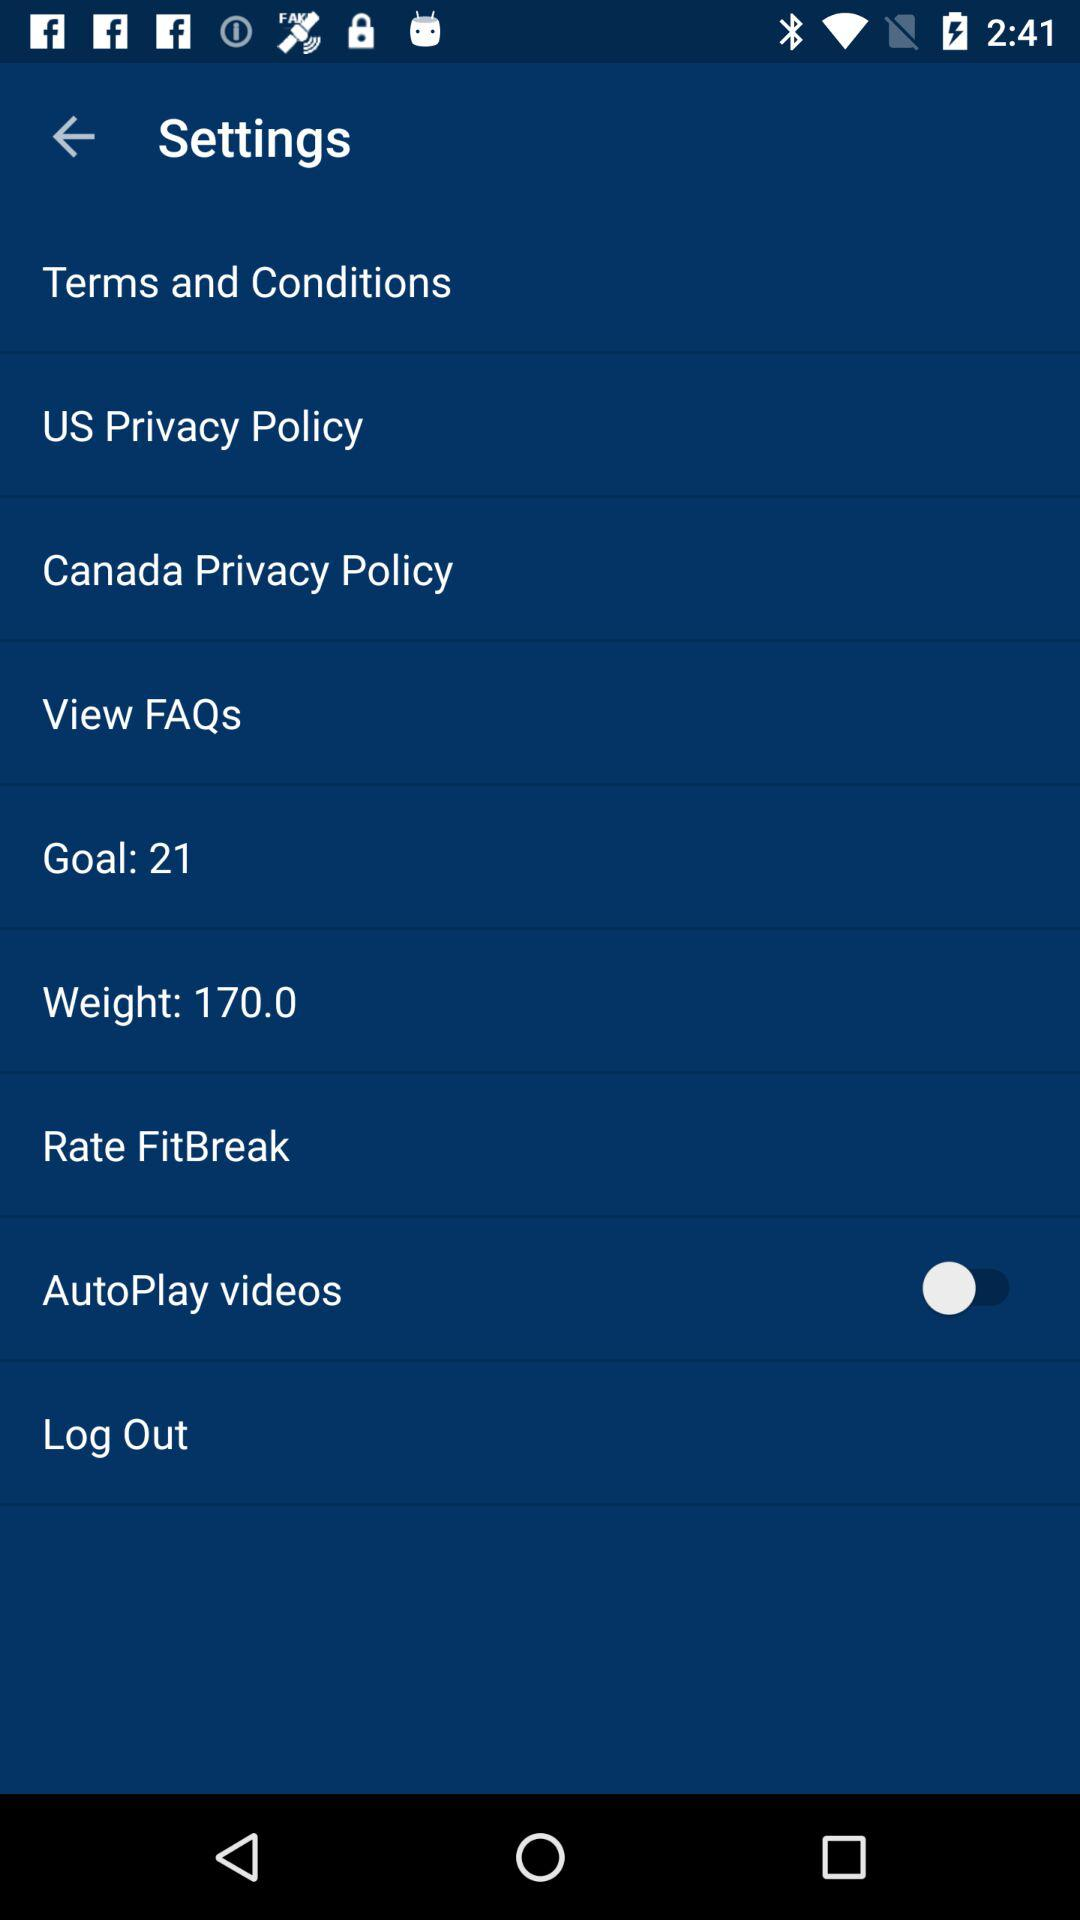What is the number of goals? The number of goals is 21. 